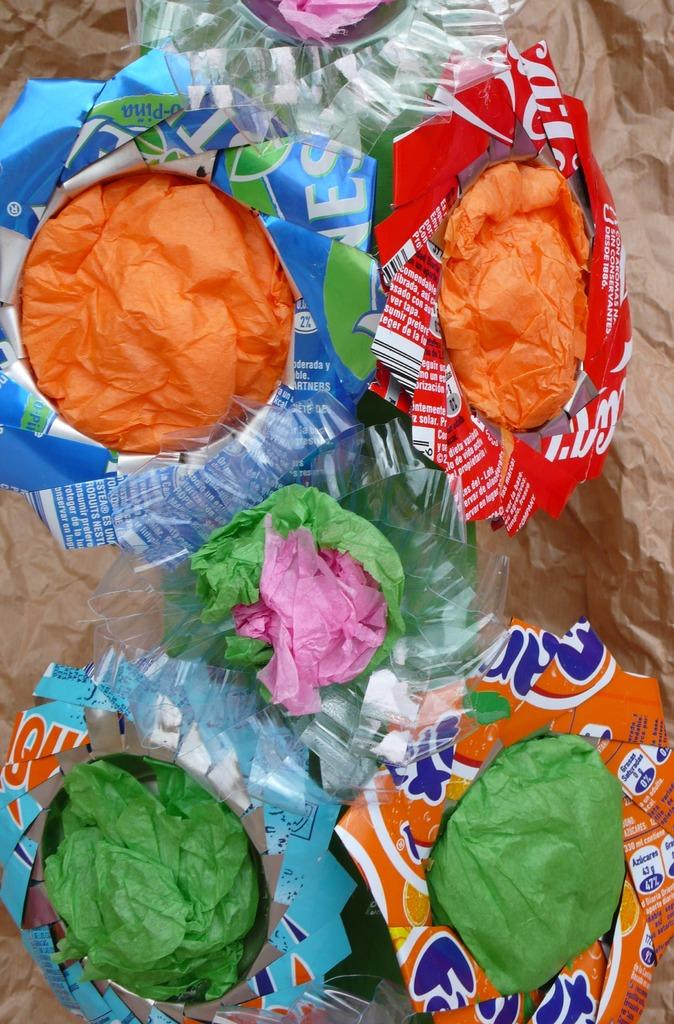What type of objects have colorful wrappers in the image? The information provided does not specify the type of objects with colorful wrappers. What can be found on the colorful wrappers? There is something written on the wrappers. How does the wilderness affect the measurement of the objects in the image? There is no wilderness present in the image, and therefore its effect on the measurement of objects cannot be determined. 